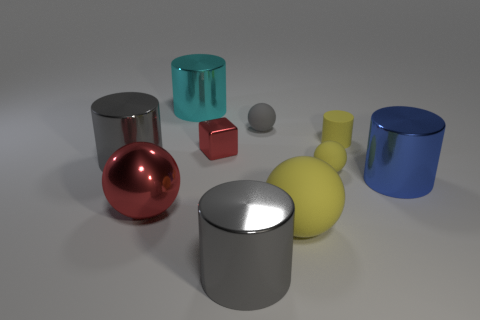The metal thing behind the tiny red metallic cube that is on the right side of the large thing behind the tiny gray sphere is what color?
Keep it short and to the point. Cyan. There is a big metal object that is behind the cube; is it the same shape as the gray metallic thing that is to the right of the cyan cylinder?
Give a very brief answer. Yes. How many cubes are there?
Your response must be concise. 1. The metallic sphere that is the same size as the cyan thing is what color?
Your answer should be compact. Red. Is the material of the yellow ball that is in front of the large red metal ball the same as the gray object behind the small red shiny object?
Your response must be concise. Yes. There is a gray shiny cylinder on the right side of the gray cylinder behind the big yellow rubber object; what size is it?
Your response must be concise. Large. There is a gray thing that is to the left of the shiny cube; what is its material?
Offer a terse response. Metal. What number of things are either large cylinders that are in front of the small gray rubber ball or large cyan shiny things that are behind the large red thing?
Provide a succinct answer. 4. There is a large blue thing that is the same shape as the cyan object; what material is it?
Give a very brief answer. Metal. Does the large object to the left of the red metallic sphere have the same color as the small thing that is in front of the small red object?
Ensure brevity in your answer.  No. 